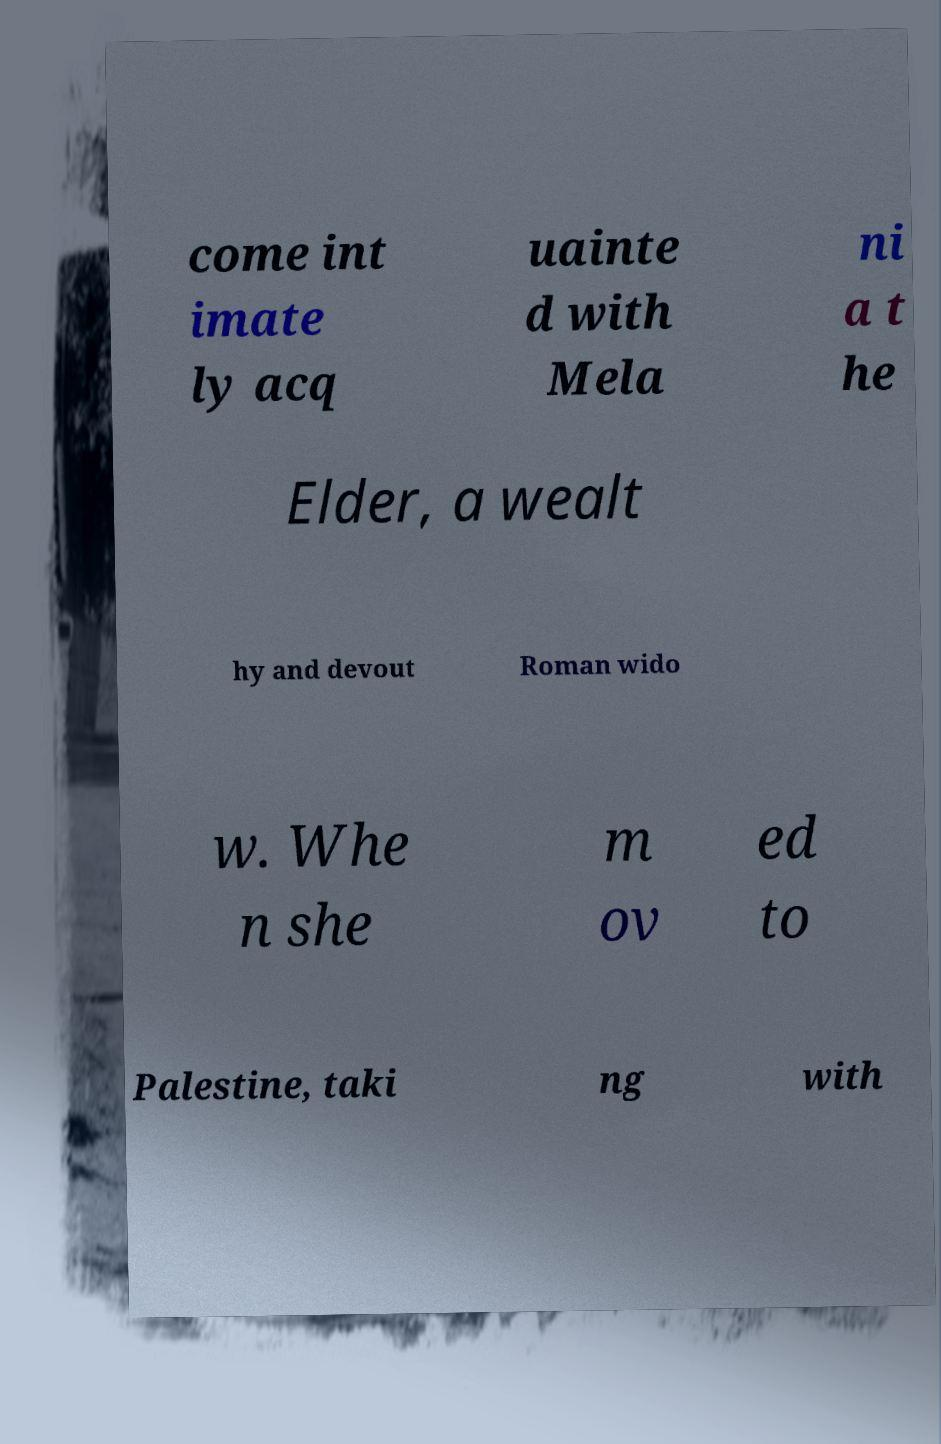There's text embedded in this image that I need extracted. Can you transcribe it verbatim? come int imate ly acq uainte d with Mela ni a t he Elder, a wealt hy and devout Roman wido w. Whe n she m ov ed to Palestine, taki ng with 